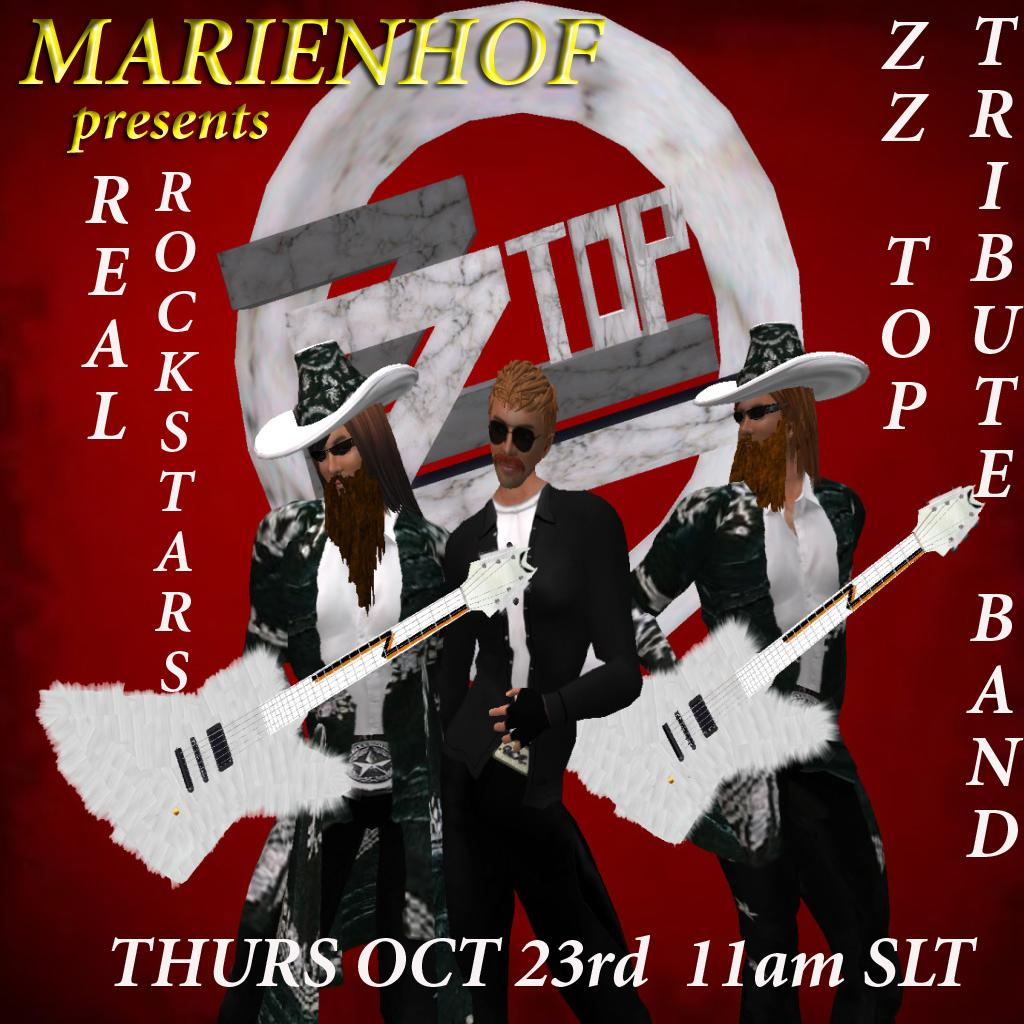What is present in the image that contains text? There is a poster in the image that contains text. What else can be seen on the poster besides text? The poster has animated images of persons. What type of building is visible in the background of the poster? There is no building visible in the image, as the focus is on the poster itself. 